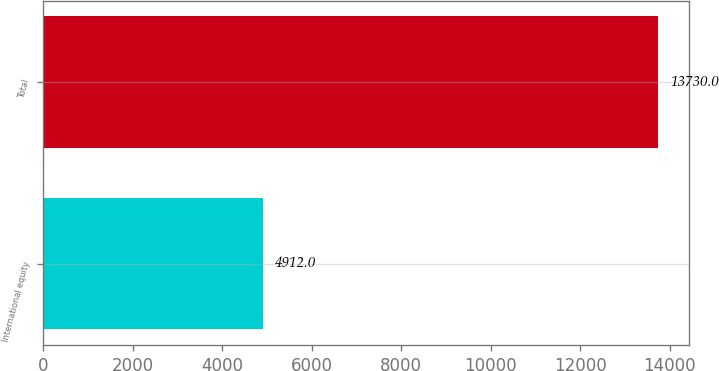<chart> <loc_0><loc_0><loc_500><loc_500><bar_chart><fcel>International equity<fcel>Total<nl><fcel>4912<fcel>13730<nl></chart> 